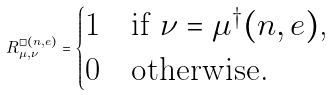Convert formula to latex. <formula><loc_0><loc_0><loc_500><loc_500>\L R ^ { \square ( n , e ) } _ { \mu , \nu } = \begin{cases} 1 & \text {if $\nu = \mu^{\dagger}(n,e)$,} \\ 0 & \text {otherwise.} \end{cases}</formula> 